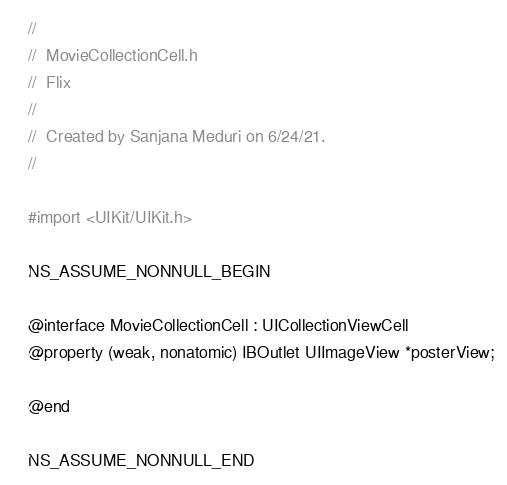Convert code to text. <code><loc_0><loc_0><loc_500><loc_500><_C_>//
//  MovieCollectionCell.h
//  Flix
//
//  Created by Sanjana Meduri on 6/24/21.
//

#import <UIKit/UIKit.h>

NS_ASSUME_NONNULL_BEGIN

@interface MovieCollectionCell : UICollectionViewCell
@property (weak, nonatomic) IBOutlet UIImageView *posterView;

@end

NS_ASSUME_NONNULL_END
</code> 